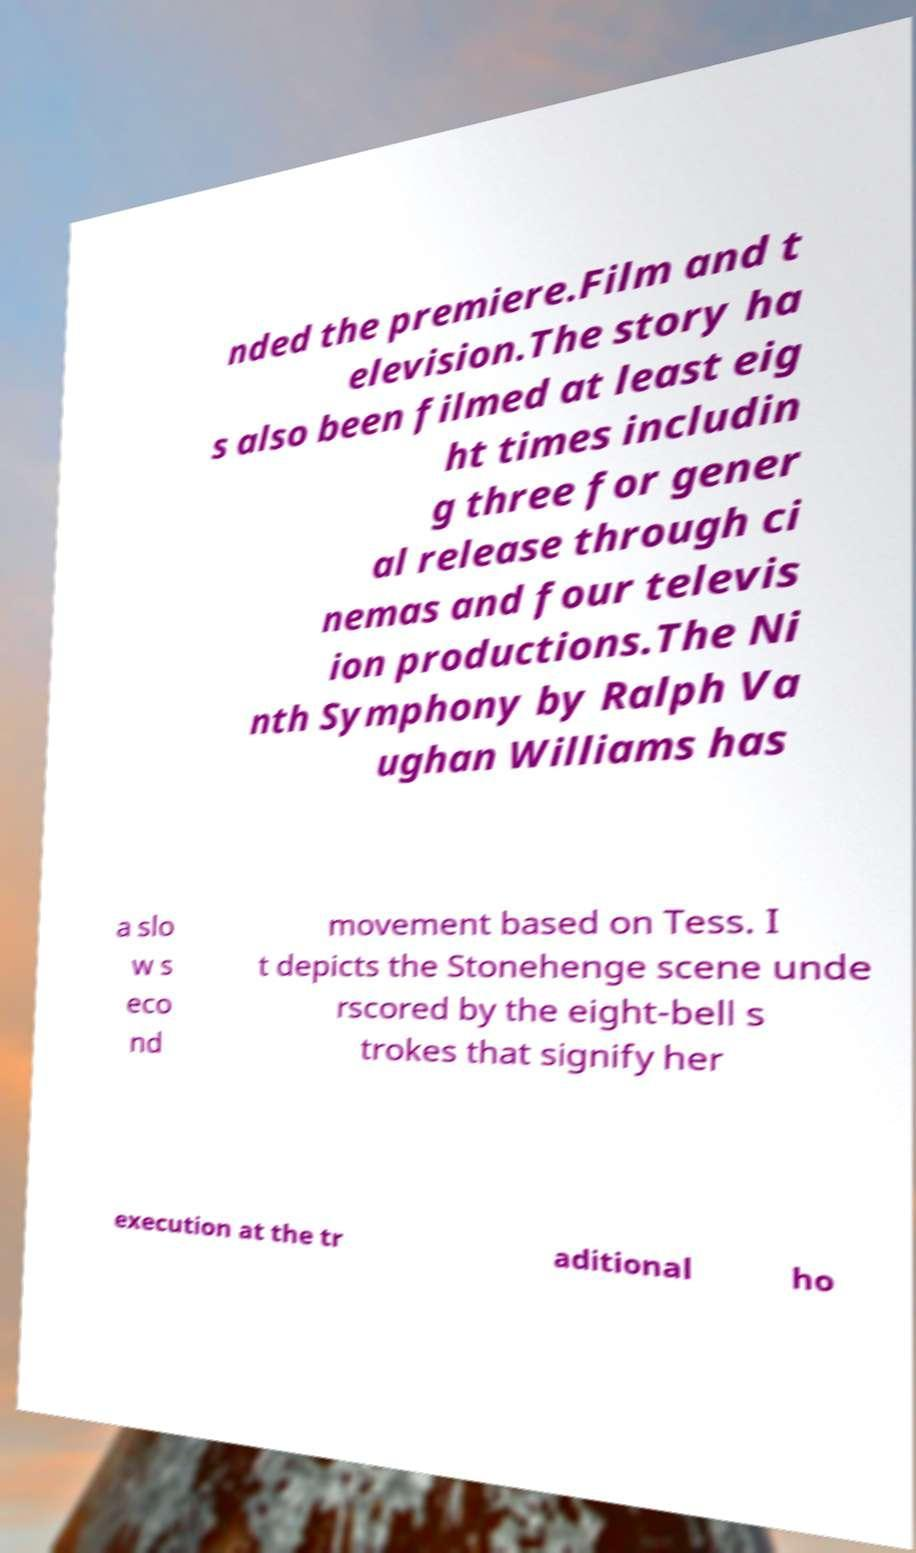Could you extract and type out the text from this image? nded the premiere.Film and t elevision.The story ha s also been filmed at least eig ht times includin g three for gener al release through ci nemas and four televis ion productions.The Ni nth Symphony by Ralph Va ughan Williams has a slo w s eco nd movement based on Tess. I t depicts the Stonehenge scene unde rscored by the eight-bell s trokes that signify her execution at the tr aditional ho 